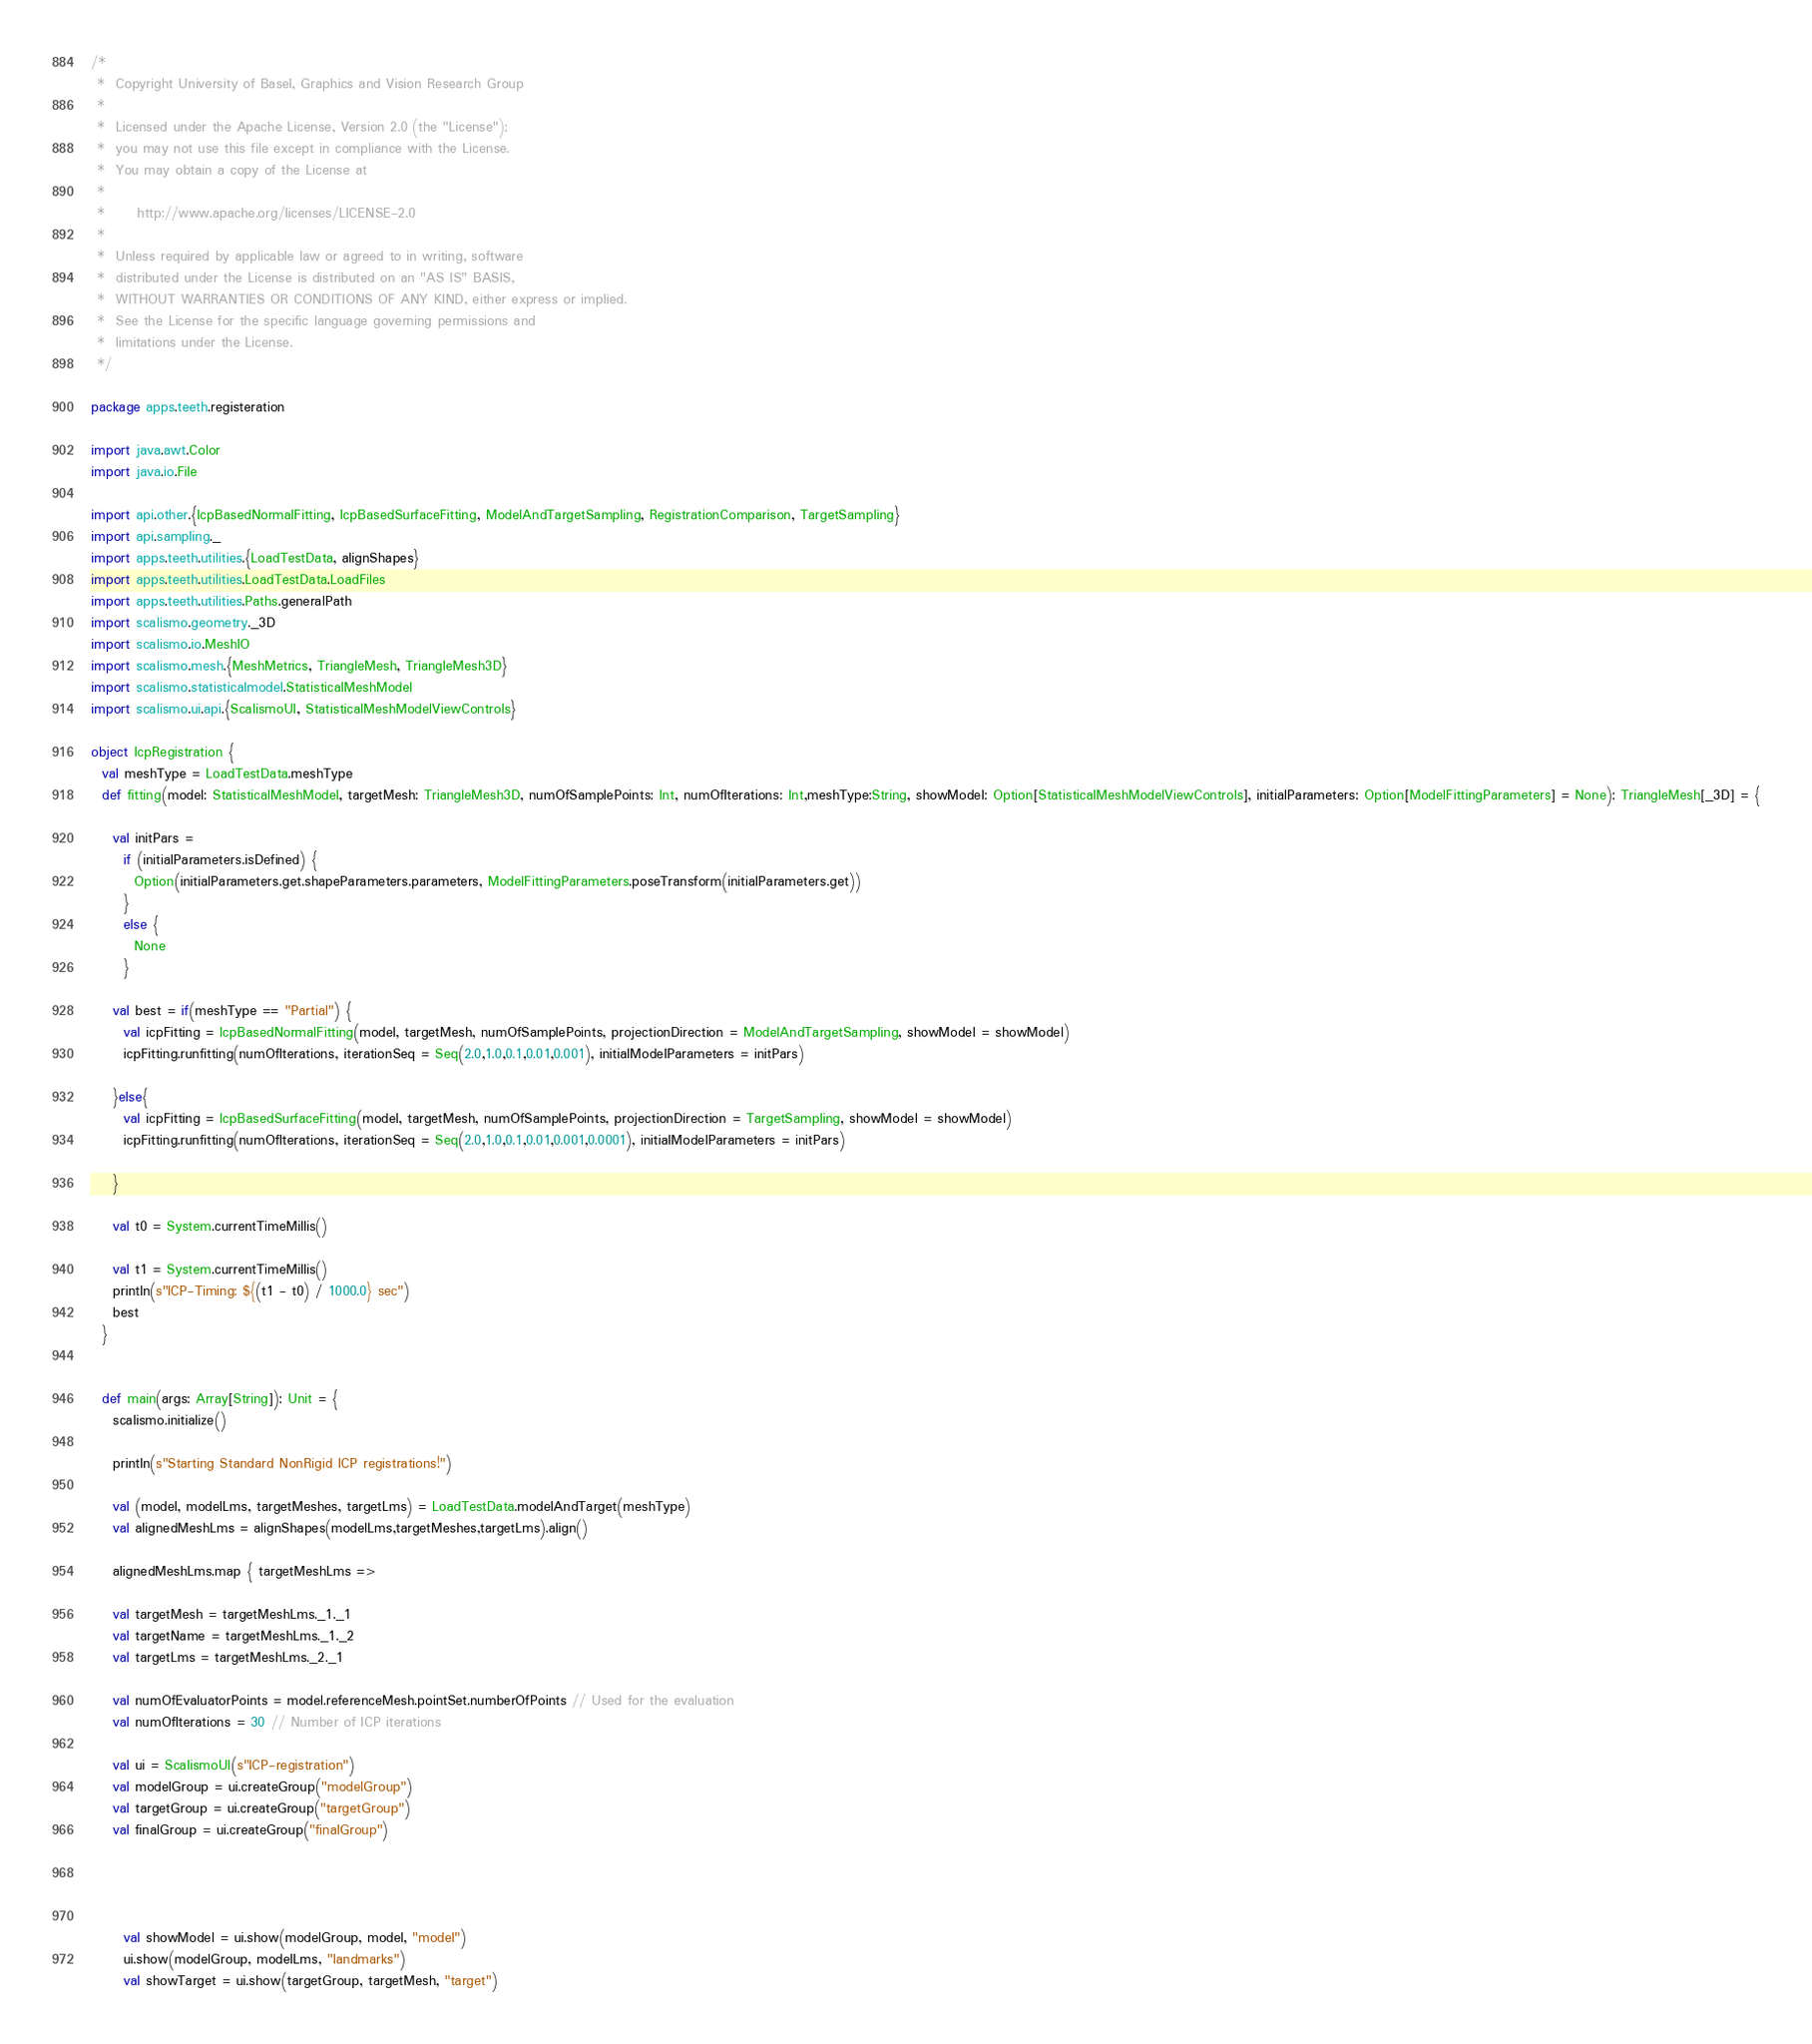Convert code to text. <code><loc_0><loc_0><loc_500><loc_500><_Scala_>/*
 *  Copyright University of Basel, Graphics and Vision Research Group
 *
 *  Licensed under the Apache License, Version 2.0 (the "License");
 *  you may not use this file except in compliance with the License.
 *  You may obtain a copy of the License at
 *
 *      http://www.apache.org/licenses/LICENSE-2.0
 *
 *  Unless required by applicable law or agreed to in writing, software
 *  distributed under the License is distributed on an "AS IS" BASIS,
 *  WITHOUT WARRANTIES OR CONDITIONS OF ANY KIND, either express or implied.
 *  See the License for the specific language governing permissions and
 *  limitations under the License.
 */

package apps.teeth.registeration

import java.awt.Color
import java.io.File

import api.other.{IcpBasedNormalFitting, IcpBasedSurfaceFitting, ModelAndTargetSampling, RegistrationComparison, TargetSampling}
import api.sampling._
import apps.teeth.utilities.{LoadTestData, alignShapes}
import apps.teeth.utilities.LoadTestData.LoadFiles
import apps.teeth.utilities.Paths.generalPath
import scalismo.geometry._3D
import scalismo.io.MeshIO
import scalismo.mesh.{MeshMetrics, TriangleMesh, TriangleMesh3D}
import scalismo.statisticalmodel.StatisticalMeshModel
import scalismo.ui.api.{ScalismoUI, StatisticalMeshModelViewControls}

object IcpRegistration {
  val meshType = LoadTestData.meshType
  def fitting(model: StatisticalMeshModel, targetMesh: TriangleMesh3D, numOfSamplePoints: Int, numOfIterations: Int,meshType:String, showModel: Option[StatisticalMeshModelViewControls], initialParameters: Option[ModelFittingParameters] = None): TriangleMesh[_3D] = {

    val initPars =
      if (initialParameters.isDefined) {
        Option(initialParameters.get.shapeParameters.parameters, ModelFittingParameters.poseTransform(initialParameters.get))
      }
      else {
        None
      }

    val best = if(meshType == "Partial") {
      val icpFitting = IcpBasedNormalFitting(model, targetMesh, numOfSamplePoints, projectionDirection = ModelAndTargetSampling, showModel = showModel)
      icpFitting.runfitting(numOfIterations, iterationSeq = Seq(2.0,1.0,0.1,0.01,0.001), initialModelParameters = initPars)

    }else{
      val icpFitting = IcpBasedSurfaceFitting(model, targetMesh, numOfSamplePoints, projectionDirection = TargetSampling, showModel = showModel)
      icpFitting.runfitting(numOfIterations, iterationSeq = Seq(2.0,1.0,0.1,0.01,0.001,0.0001), initialModelParameters = initPars)

    }

    val t0 = System.currentTimeMillis()

    val t1 = System.currentTimeMillis()
    println(s"ICP-Timing: ${(t1 - t0) / 1000.0} sec")
    best
  }


  def main(args: Array[String]): Unit = {
    scalismo.initialize()

    println(s"Starting Standard NonRigid ICP registrations!")

    val (model, modelLms, targetMeshes, targetLms) = LoadTestData.modelAndTarget(meshType)
    val alignedMeshLms = alignShapes(modelLms,targetMeshes,targetLms).align()

    alignedMeshLms.map { targetMeshLms =>

    val targetMesh = targetMeshLms._1._1
    val targetName = targetMeshLms._1._2
    val targetLms = targetMeshLms._2._1

    val numOfEvaluatorPoints = model.referenceMesh.pointSet.numberOfPoints // Used for the evaluation
    val numOfIterations = 30 // Number of ICP iterations

    val ui = ScalismoUI(s"ICP-registration")
    val modelGroup = ui.createGroup("modelGroup")
    val targetGroup = ui.createGroup("targetGroup")
    val finalGroup = ui.createGroup("finalGroup")




      val showModel = ui.show(modelGroup, model, "model")
      ui.show(modelGroup, modelLms, "landmarks")
      val showTarget = ui.show(targetGroup, targetMesh, "target")</code> 